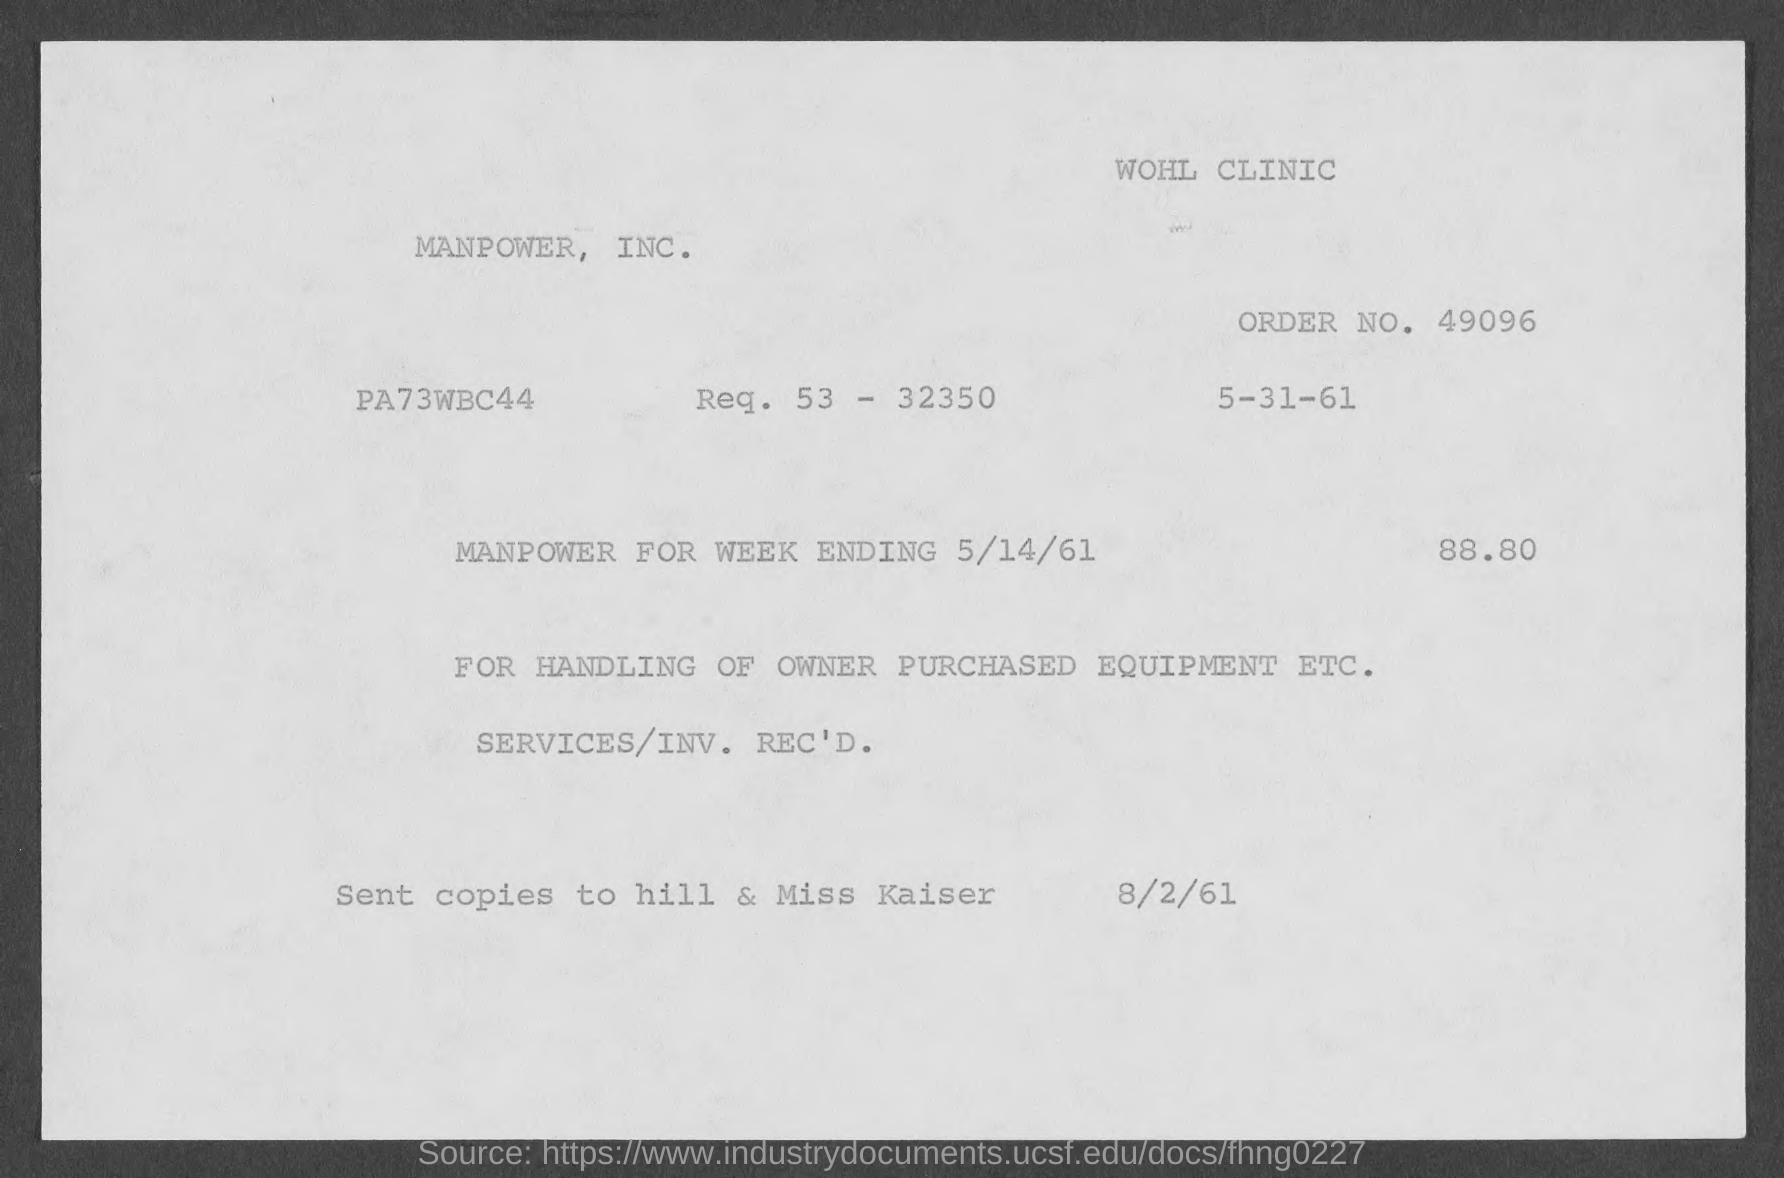Draw attention to some important aspects in this diagram. The amount mentioned in the given form is 88.80...". What is the date of manpower for the week ending May 14, 1961? The order number mentioned on the given page is 49096... The given form of a date is "5-31-61," which indicates that the date is on the 5th day of the 31st month of the year 1961. 